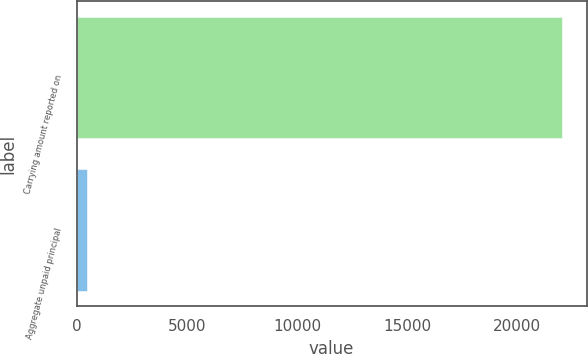<chart> <loc_0><loc_0><loc_500><loc_500><bar_chart><fcel>Carrying amount reported on<fcel>Aggregate unpaid principal<nl><fcel>22055<fcel>477<nl></chart> 